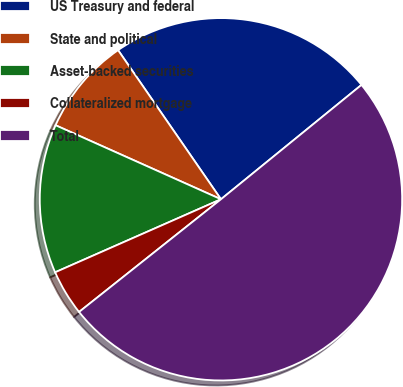<chart> <loc_0><loc_0><loc_500><loc_500><pie_chart><fcel>US Treasury and federal<fcel>State and political<fcel>Asset-backed securities<fcel>Collateralized mortgage<fcel>Total<nl><fcel>23.74%<fcel>8.69%<fcel>13.3%<fcel>4.08%<fcel>50.19%<nl></chart> 